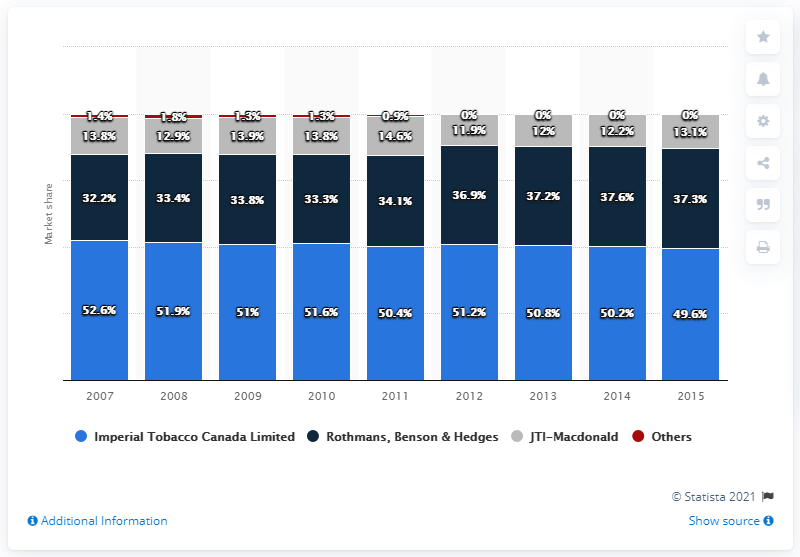Give some essential details in this illustration. JTI-Macdonald has held a smaller, but consistent share of the tobacco market in Canada. In 2015, the market share of Rothmans, Benson & Hedges was 37.3%. In 2015, Imperial Tobacco Canada Limited held a market share of 49.6%. In 2015, Imperial Tobacco Canada Limited was the leading tobacco company in Canada. 